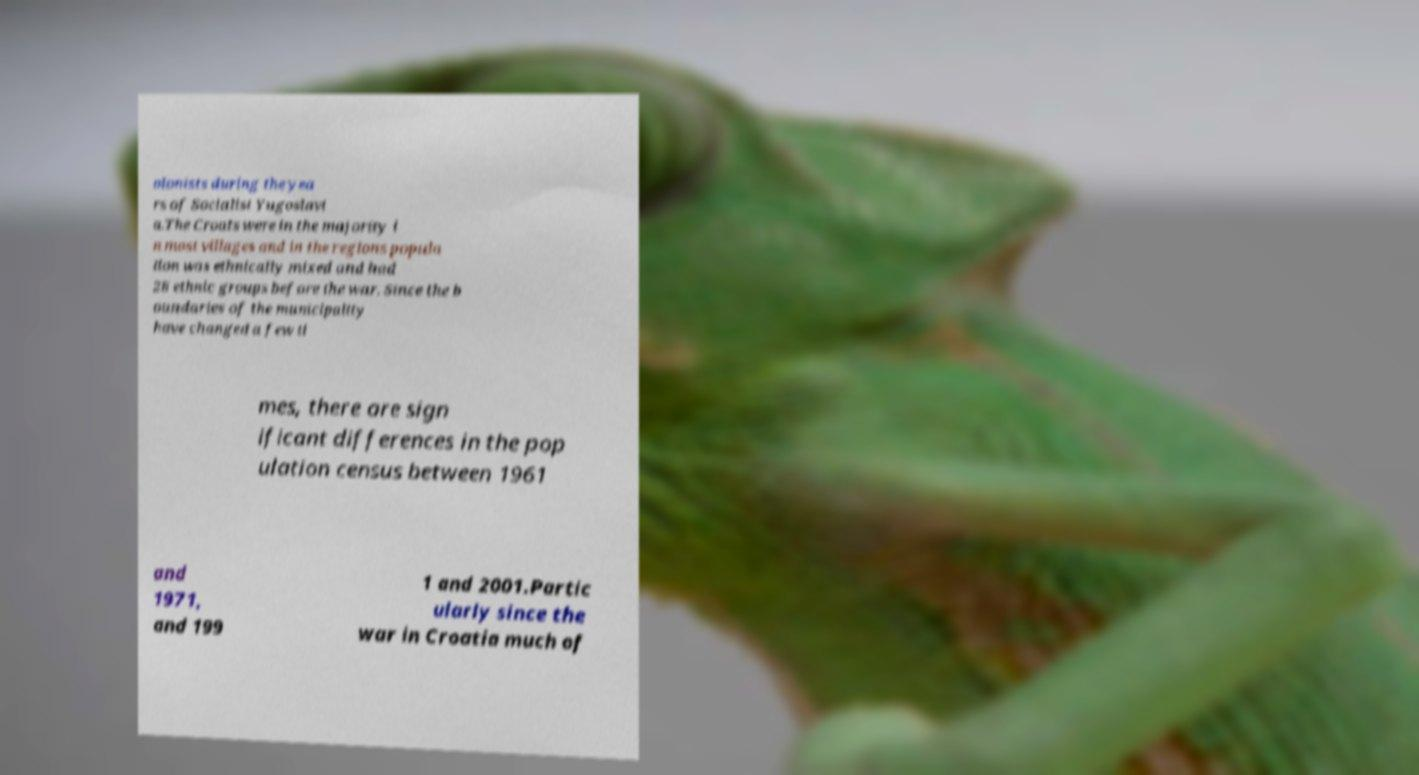Could you extract and type out the text from this image? olonists during the yea rs of Socialist Yugoslavi a.The Croats were in the majority i n most villages and in the regions popula tion was ethnically mixed and had 28 ethnic groups before the war. Since the b oundaries of the municipality have changed a few ti mes, there are sign ificant differences in the pop ulation census between 1961 and 1971, and 199 1 and 2001.Partic ularly since the war in Croatia much of 